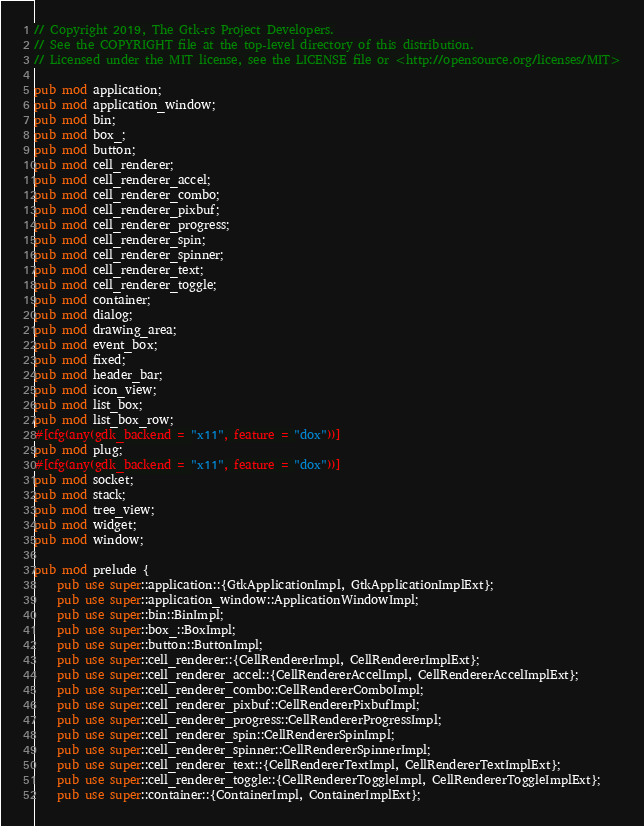<code> <loc_0><loc_0><loc_500><loc_500><_Rust_>// Copyright 2019, The Gtk-rs Project Developers.
// See the COPYRIGHT file at the top-level directory of this distribution.
// Licensed under the MIT license, see the LICENSE file or <http://opensource.org/licenses/MIT>

pub mod application;
pub mod application_window;
pub mod bin;
pub mod box_;
pub mod button;
pub mod cell_renderer;
pub mod cell_renderer_accel;
pub mod cell_renderer_combo;
pub mod cell_renderer_pixbuf;
pub mod cell_renderer_progress;
pub mod cell_renderer_spin;
pub mod cell_renderer_spinner;
pub mod cell_renderer_text;
pub mod cell_renderer_toggle;
pub mod container;
pub mod dialog;
pub mod drawing_area;
pub mod event_box;
pub mod fixed;
pub mod header_bar;
pub mod icon_view;
pub mod list_box;
pub mod list_box_row;
#[cfg(any(gdk_backend = "x11", feature = "dox"))]
pub mod plug;
#[cfg(any(gdk_backend = "x11", feature = "dox"))]
pub mod socket;
pub mod stack;
pub mod tree_view;
pub mod widget;
pub mod window;

pub mod prelude {
    pub use super::application::{GtkApplicationImpl, GtkApplicationImplExt};
    pub use super::application_window::ApplicationWindowImpl;
    pub use super::bin::BinImpl;
    pub use super::box_::BoxImpl;
    pub use super::button::ButtonImpl;
    pub use super::cell_renderer::{CellRendererImpl, CellRendererImplExt};
    pub use super::cell_renderer_accel::{CellRendererAccelImpl, CellRendererAccelImplExt};
    pub use super::cell_renderer_combo::CellRendererComboImpl;
    pub use super::cell_renderer_pixbuf::CellRendererPixbufImpl;
    pub use super::cell_renderer_progress::CellRendererProgressImpl;
    pub use super::cell_renderer_spin::CellRendererSpinImpl;
    pub use super::cell_renderer_spinner::CellRendererSpinnerImpl;
    pub use super::cell_renderer_text::{CellRendererTextImpl, CellRendererTextImplExt};
    pub use super::cell_renderer_toggle::{CellRendererToggleImpl, CellRendererToggleImplExt};
    pub use super::container::{ContainerImpl, ContainerImplExt};</code> 